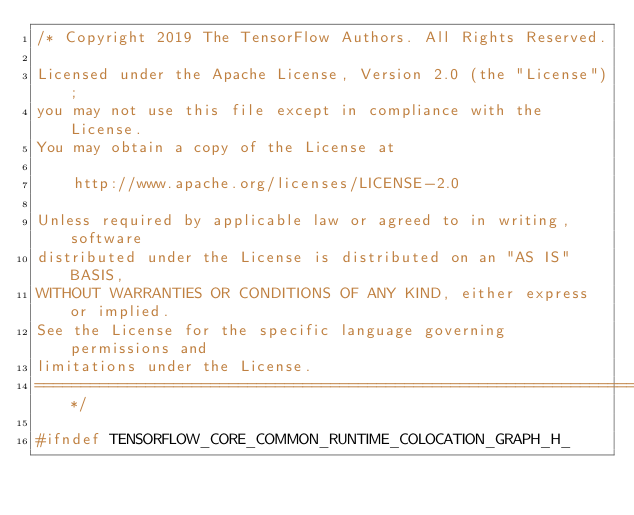Convert code to text. <code><loc_0><loc_0><loc_500><loc_500><_C_>/* Copyright 2019 The TensorFlow Authors. All Rights Reserved.

Licensed under the Apache License, Version 2.0 (the "License");
you may not use this file except in compliance with the License.
You may obtain a copy of the License at

    http://www.apache.org/licenses/LICENSE-2.0

Unless required by applicable law or agreed to in writing, software
distributed under the License is distributed on an "AS IS" BASIS,
WITHOUT WARRANTIES OR CONDITIONS OF ANY KIND, either express or implied.
See the License for the specific language governing permissions and
limitations under the License.
==============================================================================*/

#ifndef TENSORFLOW_CORE_COMMON_RUNTIME_COLOCATION_GRAPH_H_</code> 